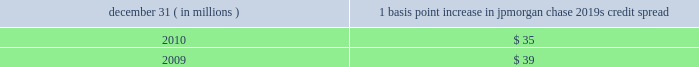Management 2019s discussion and analysis 144 jpmorgan chase & co./2010 annual report compared with $ 57 million for 2009 .
Decreases in cio and mort- gage banking var for 2010 were again driven by the decline in market volatility and position changes .
The decline in mortgage banking var at december 31 , 2010 , reflects management 2019s deci- sion to reduce risk given market volatility at the time .
The firm 2019s average ib and other var diversification benefit was $ 59 million or 37% ( 37 % ) of the sum for 2010 , compared with $ 82 million or 28% ( 28 % ) of the sum for 2009 .
The firm experienced an increase in the diversification benefit in 2010 as positions changed and correla- tions decreased .
In general , over the course of the year , var expo- sure can vary significantly as positions change , market volatility fluctuates and diversification benefits change .
Var back-testing the firm conducts daily back-testing of var against its market risk- related revenue , which is defined as the change in value of : princi- pal transactions revenue for ib and cio ( less private equity gains/losses and revenue from longer-term cio investments ) ; trading-related net interest income for ib , cio and mortgage bank- ing ; ib brokerage commissions , underwriting fees or other revenue ; revenue from syndicated lending facilities that the firm intends to distribute ; and mortgage fees and related income for the firm 2019s mortgage pipeline and warehouse loans , msrs , and all related hedges .
Daily firmwide market risk 2013related revenue excludes gains and losses from dva .
The following histogram illustrates the daily market risk 2013related gains and losses for ib , cio and mortgage banking positions for 2010 .
The chart shows that the firm posted market risk 2013related gains on 248 out of 261 days in this period , with 12 days exceeding $ 210 million .
The inset graph looks at those days on which the firm experienced losses and depicts the amount by which the 95% ( 95 % ) confidence-level var ex- ceeded the actual loss on each of those days .
During 2010 , losses were sustained on 13 days , none of which exceeded the var measure .
Daily ib and other market risk-related gains and losses ( 95% ( 95 % ) confidence-level var ) year ended december 31 , 2010 average daily revenue : $ 87 million $ in millions $ in millions daily ib and other var less market risk-related losses the table provides information about the gross sensitivity of dva to a one-basis-point increase in jpmorgan chase 2019s credit spreads .
This sensitivity represents the impact from a one-basis-point parallel shift in jpmorgan chase 2019s entire credit curve .
As credit curves do not typically move in a parallel fashion , the sensitivity multiplied by the change in spreads at a single maturity point may not be representative of the actual revenue recognized .
Debit valuation adjustment sensitivity 1 basis point increase in december 31 , ( in millions ) jpmorgan chase 2019s credit spread .

What was the ratio of the basis point increase in 2010 compared to 2009? 
Computations: (35 / 39)
Answer: 0.89744. 